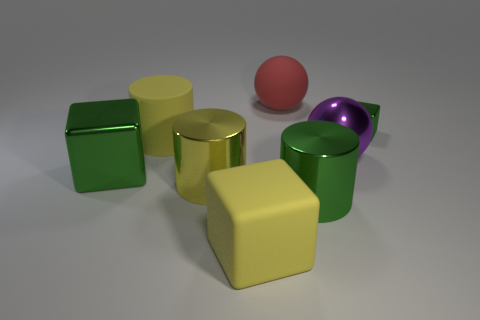Is the number of small green metallic blocks greater than the number of green cubes?
Make the answer very short. No. How many other objects are there of the same shape as the big yellow metallic thing?
Your answer should be compact. 2. Is the matte cube the same color as the metal sphere?
Give a very brief answer. No. There is a large object that is both in front of the red sphere and behind the purple metal thing; what material is it made of?
Your answer should be very brief. Rubber. The red sphere has what size?
Your response must be concise. Large. What number of large rubber blocks are to the left of the shiny block left of the big block that is on the right side of the big shiny block?
Your response must be concise. 0. The green object on the left side of the big yellow object that is in front of the big green cylinder is what shape?
Give a very brief answer. Cube. There is a green object that is the same shape as the yellow metal thing; what is its size?
Ensure brevity in your answer.  Large. Are there any other things that have the same size as the metallic ball?
Keep it short and to the point. Yes. What color is the big cylinder that is on the left side of the large yellow metallic thing?
Give a very brief answer. Yellow. 